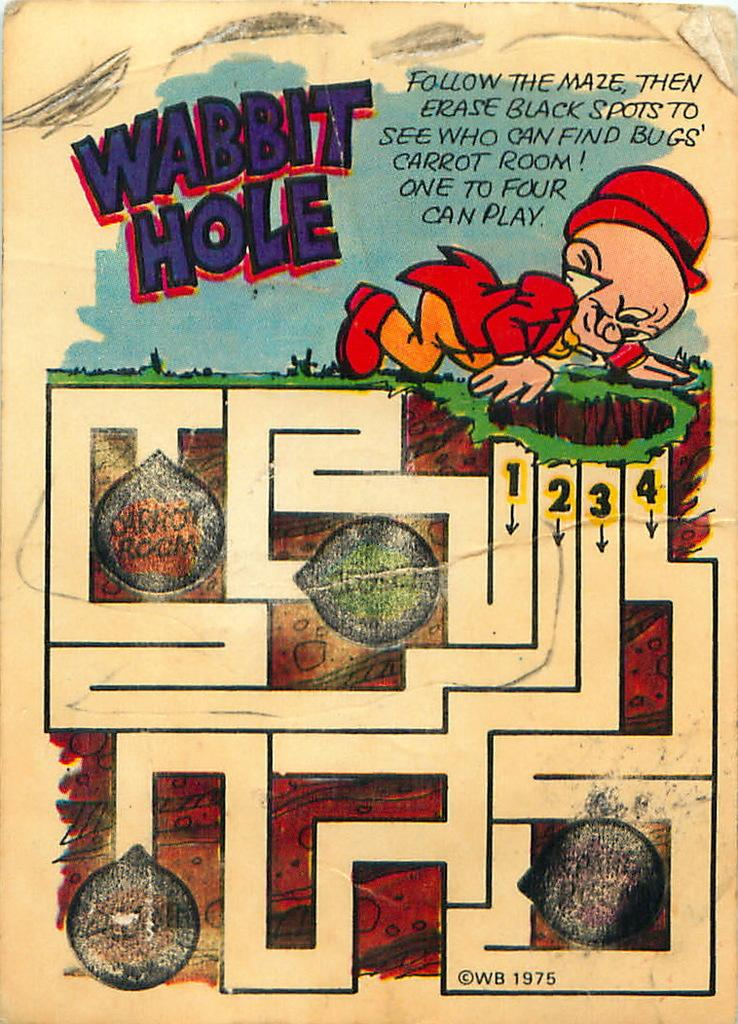<image>
Present a compact description of the photo's key features. A cartoon maze on a page with the title wabbit hole written on the top. 